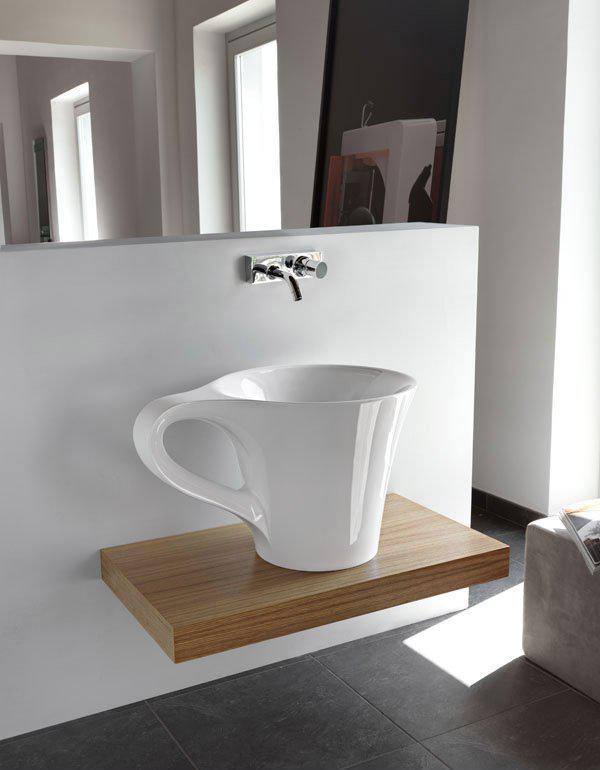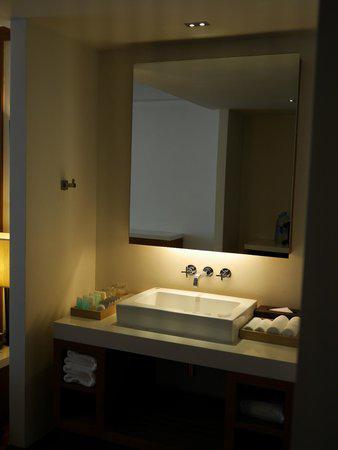The first image is the image on the left, the second image is the image on the right. For the images shown, is this caption "In at least one image there is a raised circle basin sink with a mirror behind it." true? Answer yes or no. No. The first image is the image on the left, the second image is the image on the right. For the images displayed, is the sentence "One image features a square white sink under a mirror with a counter that spans its tight stall space and does not have a counter beneath it." factually correct? Answer yes or no. No. 